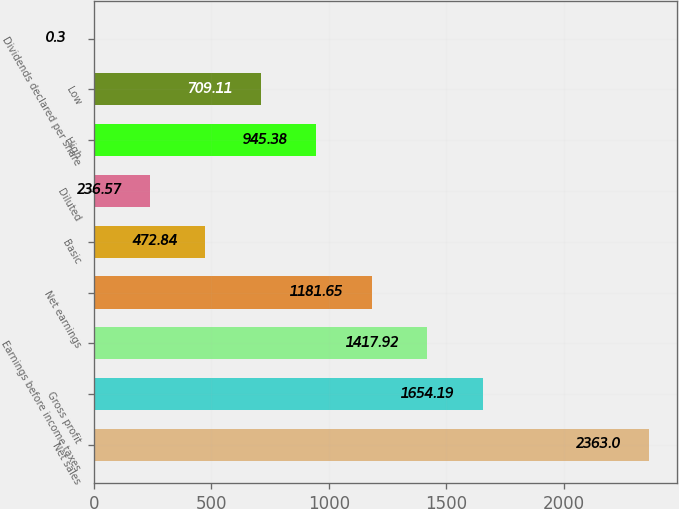Convert chart to OTSL. <chart><loc_0><loc_0><loc_500><loc_500><bar_chart><fcel>Net sales<fcel>Gross profit<fcel>Earnings before income taxes<fcel>Net earnings<fcel>Basic<fcel>Diluted<fcel>High<fcel>Low<fcel>Dividends declared per share<nl><fcel>2363<fcel>1654.19<fcel>1417.92<fcel>1181.65<fcel>472.84<fcel>236.57<fcel>945.38<fcel>709.11<fcel>0.3<nl></chart> 